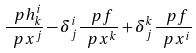Convert formula to latex. <formula><loc_0><loc_0><loc_500><loc_500>\frac { \ p h ^ { i } _ { k } } { \ p x ^ { j } } - \delta ^ { i } _ { j } \frac { \ p f } { \ p x ^ { k } } + \delta ^ { k } _ { j } \frac { \ p f } { \ p x ^ { i } }</formula> 